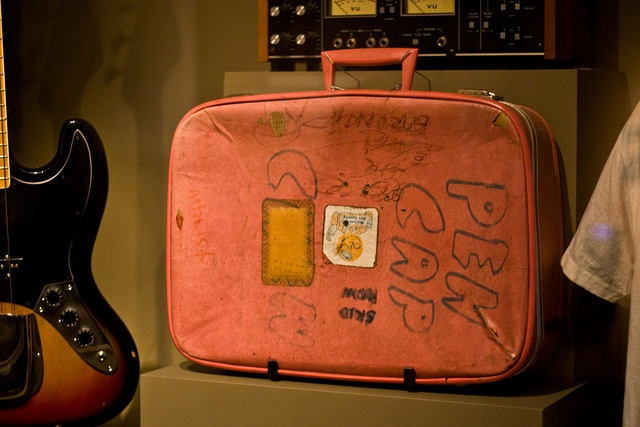Describe the objects in this image and their specific colors. I can see suitcase in olive, brown, red, and salmon tones and people in olive, gray, tan, and brown tones in this image. 